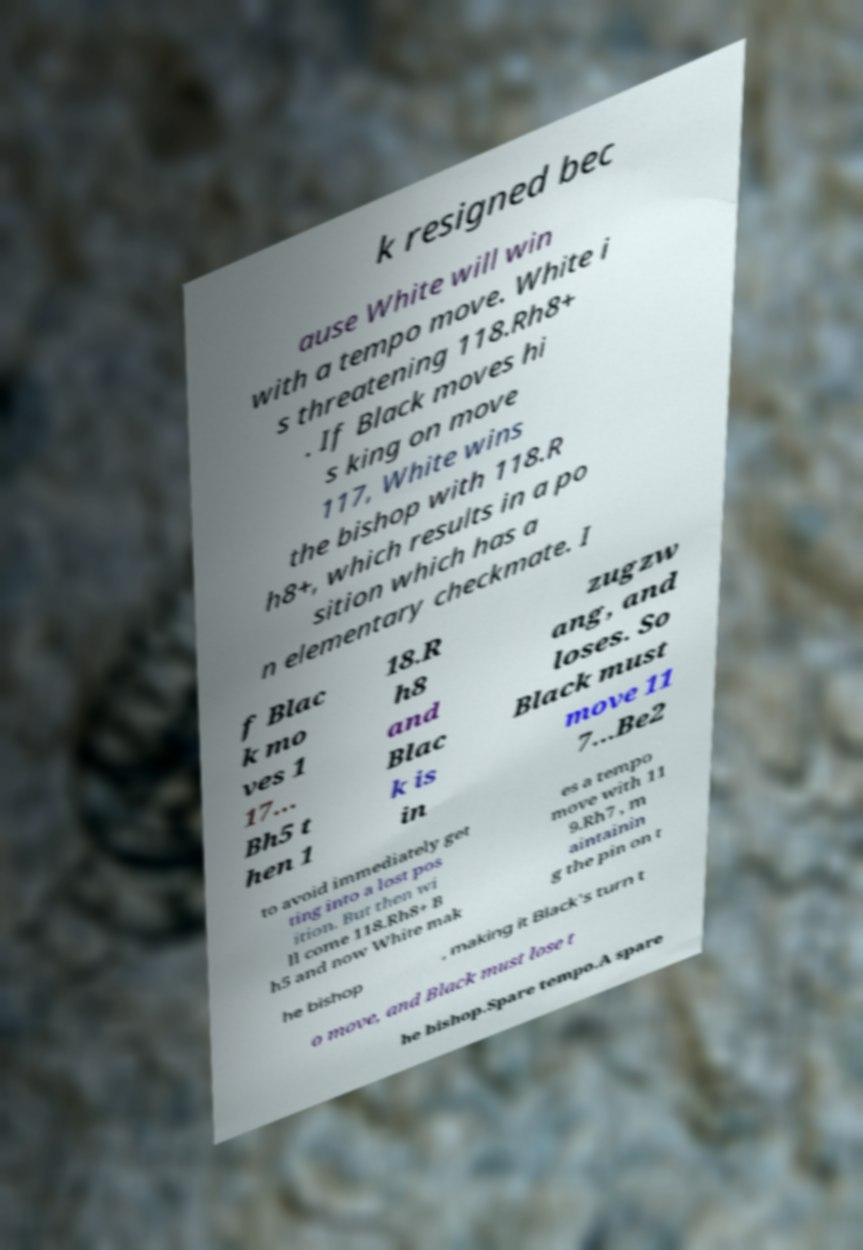There's text embedded in this image that I need extracted. Can you transcribe it verbatim? k resigned bec ause White will win with a tempo move. White i s threatening 118.Rh8+ . If Black moves hi s king on move 117, White wins the bishop with 118.R h8+, which results in a po sition which has a n elementary checkmate. I f Blac k mo ves 1 17... Bh5 t hen 1 18.R h8 and Blac k is in zugzw ang, and loses. So Black must move 11 7...Be2 to avoid immediately get ting into a lost pos ition. But then wi ll come 118.Rh8+ B h5 and now White mak es a tempo move with 11 9.Rh7 , m aintainin g the pin on t he bishop , making it Black's turn t o move, and Black must lose t he bishop.Spare tempo.A spare 